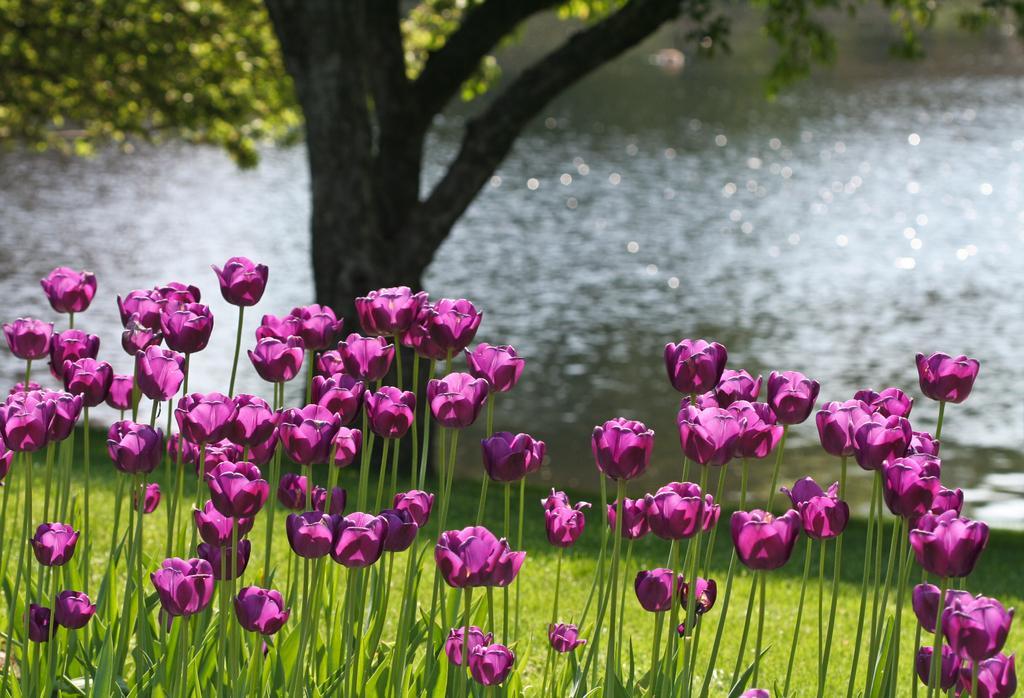Describe this image in one or two sentences. This is an edited image. In this image, we can see some plants with flowers which are in pink in color. In this image, we can see some plants with flowers which are in pink in color. In the background, we can see a tree and water in a lake. At the bottom, we can see a grass. 